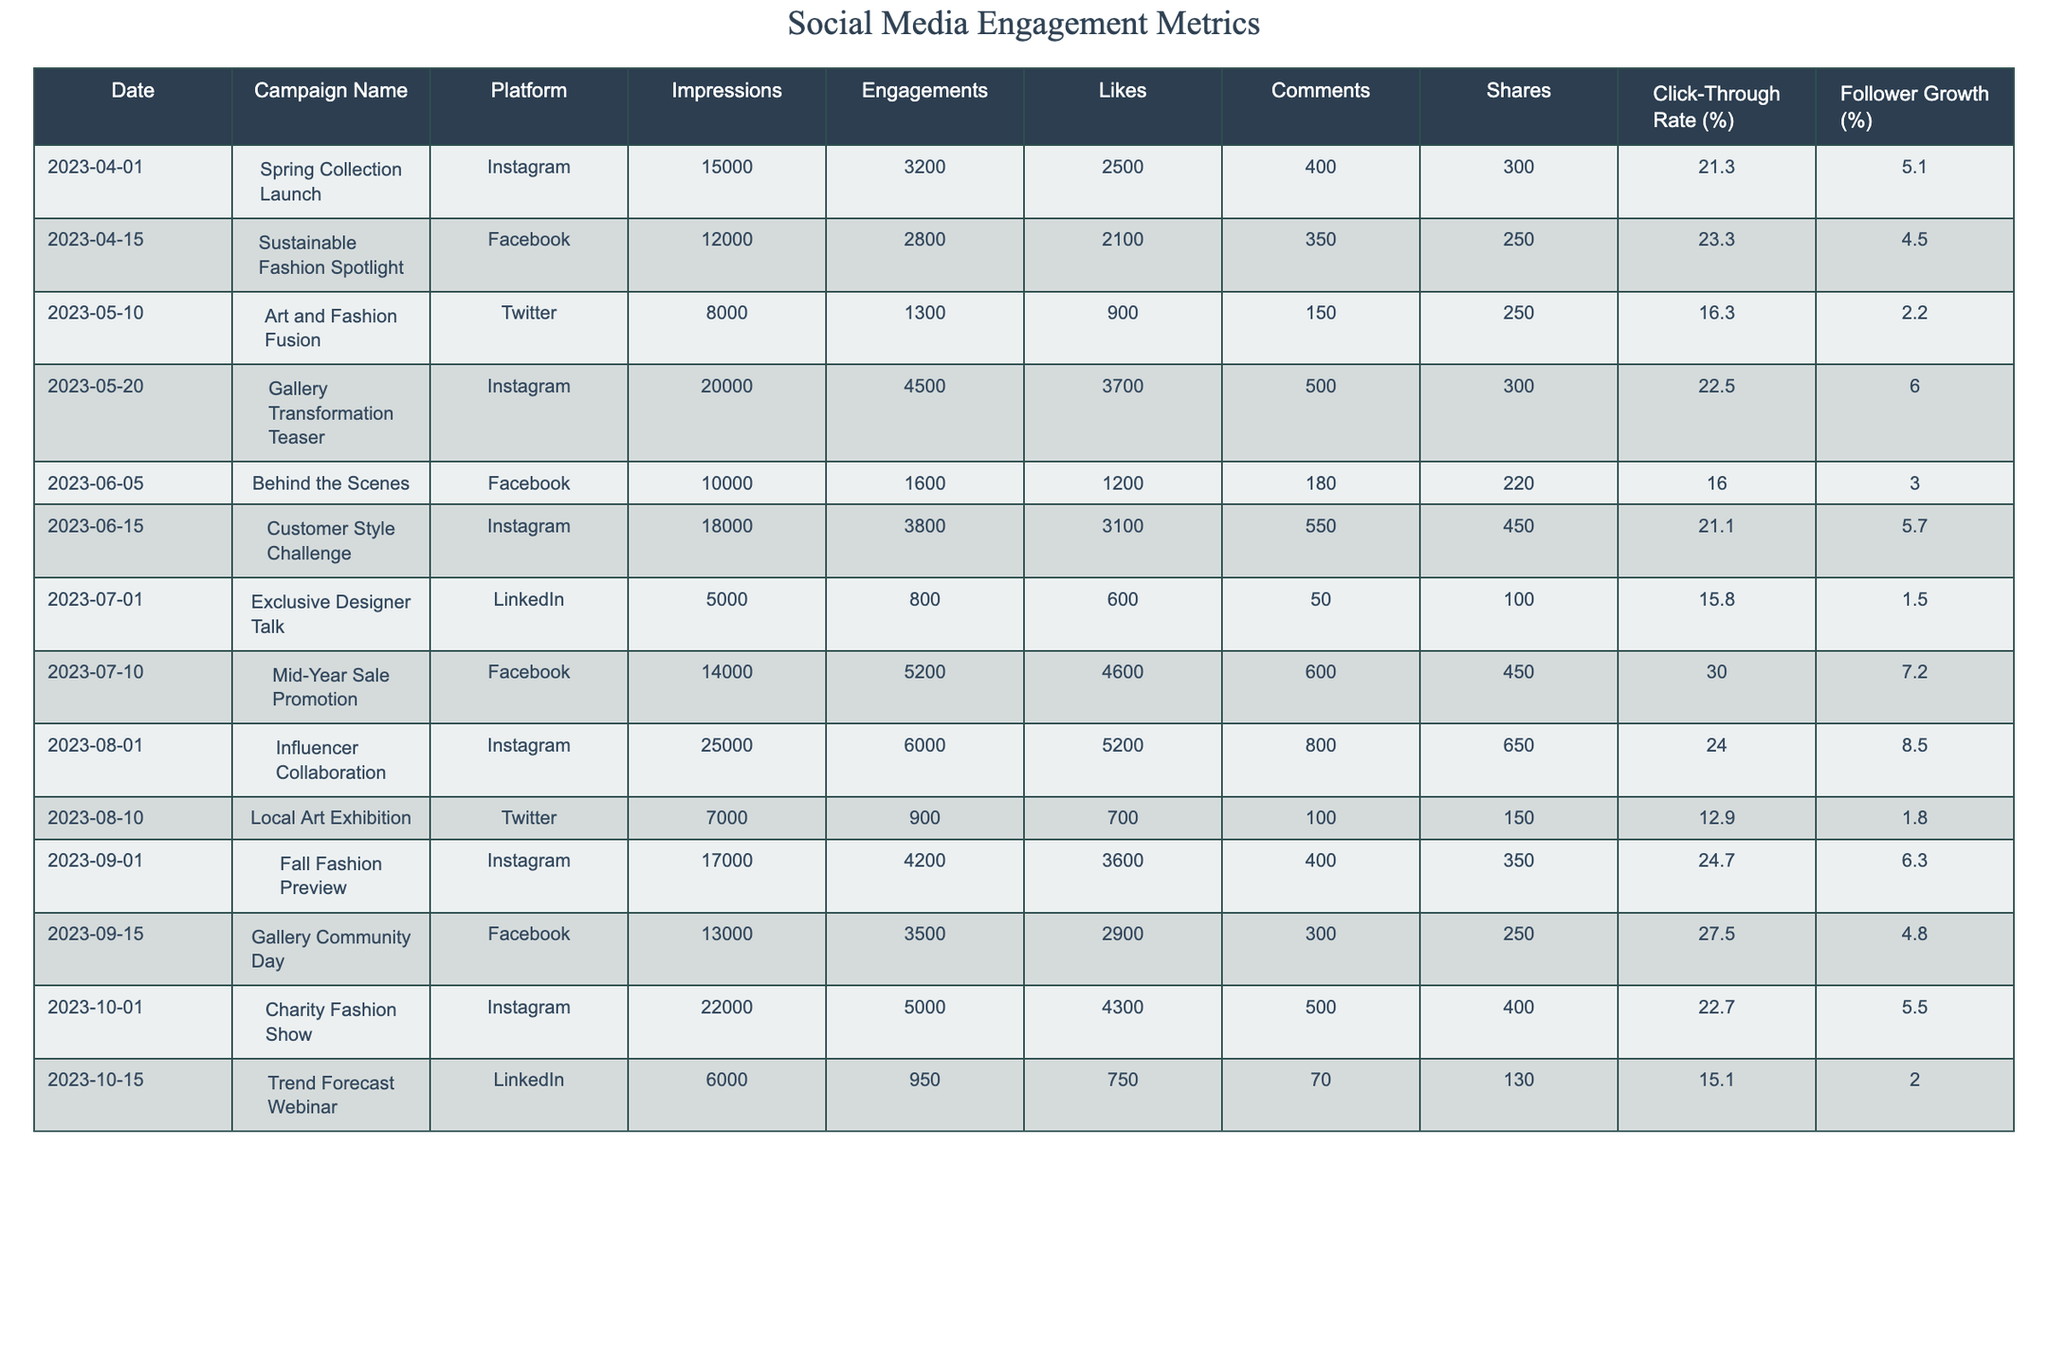What was the engagement rate for the Spring Collection Launch campaign? To find the engagement rate, divide the total engagements (3200) by the total impressions (15000) and then multiply by 100. (3200/15000) * 100 = 21.3%.
Answer: 21.3% Which campaign had the highest number of shares, and how many were there? The Influencer Collaboration campaign had the highest number of shares with a total of 650.
Answer: Influencer Collaboration, 650 What was the average click-through rate across all campaigns? To calculate the average click-through rate, sum all the click-through rates (21.3 + 23.3 + 16.3 + 22.5 + 16.0 + 21.1 + 15.8 + 30.0 + 24.0 + 12.9 + 24.7 + 27.5 + 22.7 + 15.1) which equals  24.1 and then divide by the number of campaigns, which is 14. (24.1/14) = 17.2%.
Answer: 17.2% Did the Customer Style Challenge generate more engagements than the Behind the Scenes campaign? The Customer Style Challenge had 3800 engagements, while the Behind the Scenes campaign had only 1600 engagements. Thus, yes, the Customer Style Challenge generated more engagements.
Answer: Yes What is the percentage increase in follower growth from the Mid-Year Sale Promotion campaign to the Influencer Collaboration campaign? The follower growth for Mid-Year Sale Promotion was 7.2% and for Influencer Collaboration was 8.5%. To find the percentage increase, subtract the two percentages and then divide by the original value (8.5 - 7.2) / 7.2 * 100, which equals approximately 18.06%.
Answer: 18.06% What was the total number of impressions for campaigns held on Instagram over the last six months? The impressions for Instagram campaigns were: 15000 (Spring Collection Launch) + 20000 (Gallery Transformation Teaser) + 18000 (Customer Style Challenge) + 25000 (Influencer Collaboration) + 17000 (Fall Fashion Preview) + 22000 (Charity Fashion Show). Summing these gives a total of 117000 impressions.
Answer: 117000 Which platform had the lowest average engagements based on the campaigns conducted? The Twitter platform had the lowest total engagements: 1300 (Art and Fashion Fusion) + 900 (Local Art Exhibition) = 2200, divided by two campaigns gives an average of 1100 engagements per campaign.
Answer: Twitter How many comments were generated in total across all campaigns? Total comments can be calculated by adding together all the comments: 400 + 350 + 150 + 500 + 180 + 550 + 50 + 600 + 800 + 100 + 400 + 300 + 500 + 70, which totals 4050 comments.
Answer: 4050 Which campaign recorded the highest follower growth percentage, and what was it? The campaign with the highest follower growth percentage was the Influencer Collaboration with a growth of 8.5%.
Answer: Influencer Collaboration, 8.5% Did any LinkedIn campaigns have a higher click-through rate than the Facebook campaigns? The LinkedIn campaigns had click-through rates of 15.8% (Exclusive Designer Talk) and 15.1% (Trend Forecast Webinar) while Facebook campaigns had rates: 23.3%, 16.0%, 30.0%, 27.5%. Comparing these, LinkedIn campaigns did not have any higher rates.
Answer: No 